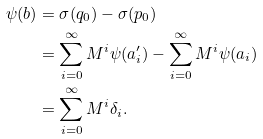<formula> <loc_0><loc_0><loc_500><loc_500>\psi ( b ) & = \sigma ( q _ { 0 } ) - \sigma ( p _ { 0 } ) \\ & = \sum _ { i = 0 } ^ { \infty } M ^ { i } \psi ( a _ { i } ^ { \prime } ) - \sum _ { i = 0 } ^ { \infty } M ^ { i } \psi ( a _ { i } ) \\ & = \sum _ { i = 0 } ^ { \infty } M ^ { i } \delta _ { i } .</formula> 